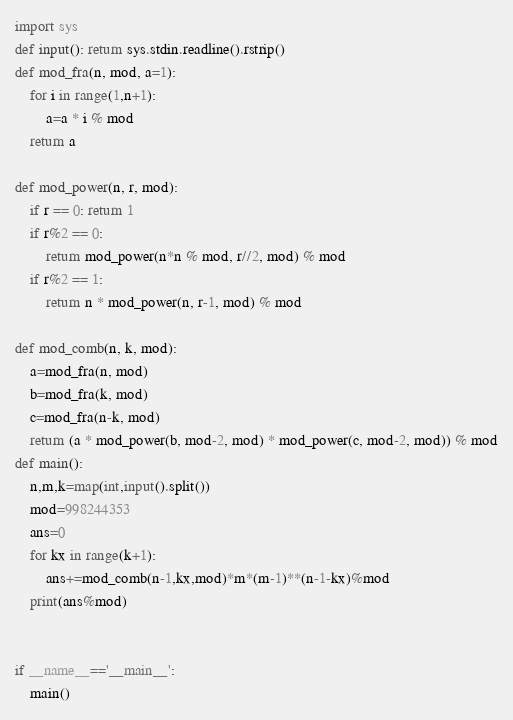Convert code to text. <code><loc_0><loc_0><loc_500><loc_500><_Python_>import sys
def input(): return sys.stdin.readline().rstrip()
def mod_fra(n, mod, a=1):
    for i in range(1,n+1):
        a=a * i % mod
    return a

def mod_power(n, r, mod):
    if r == 0: return 1
    if r%2 == 0:
        return mod_power(n*n % mod, r//2, mod) % mod
    if r%2 == 1:
        return n * mod_power(n, r-1, mod) % mod

def mod_comb(n, k, mod):
    a=mod_fra(n, mod)
    b=mod_fra(k, mod)
    c=mod_fra(n-k, mod)
    return (a * mod_power(b, mod-2, mod) * mod_power(c, mod-2, mod)) % mod
def main():
    n,m,k=map(int,input().split())
    mod=998244353
    ans=0
    for kx in range(k+1):
        ans+=mod_comb(n-1,kx,mod)*m*(m-1)**(n-1-kx)%mod
    print(ans%mod)


if __name__=='__main__':
    main()</code> 